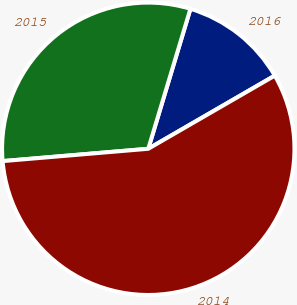Convert chart. <chart><loc_0><loc_0><loc_500><loc_500><pie_chart><fcel>2016<fcel>2015<fcel>2014<nl><fcel>12.0%<fcel>31.0%<fcel>57.0%<nl></chart> 